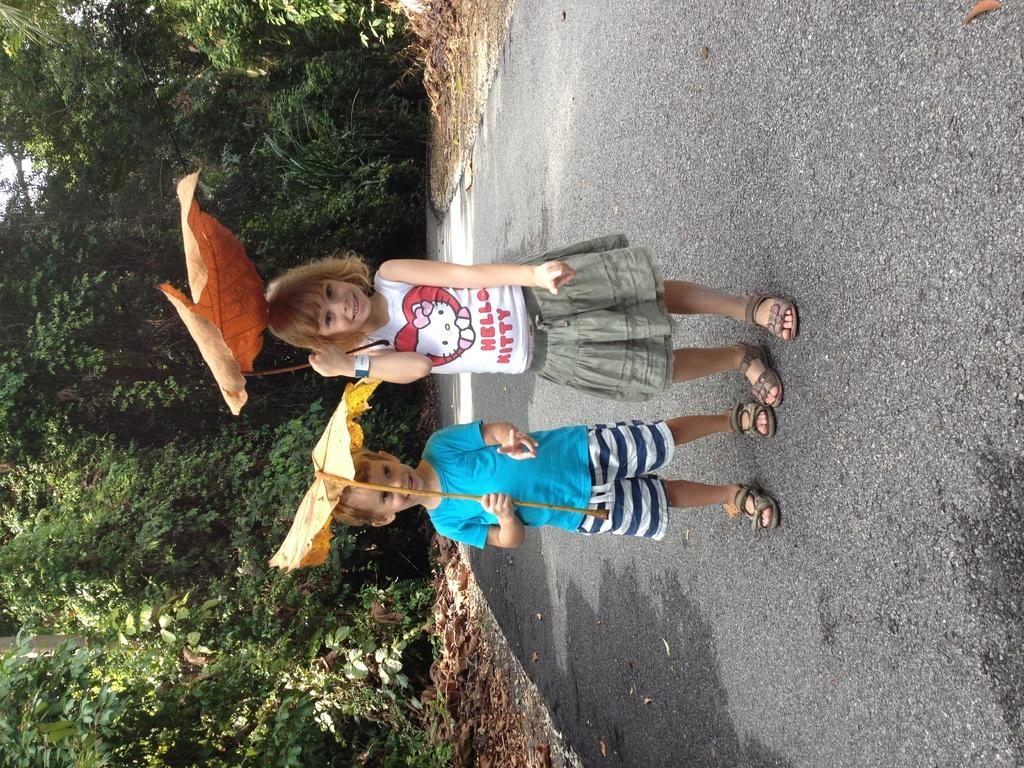<image>
Give a short and clear explanation of the subsequent image. A young girl wears a shirt that that reads HELLO KITTY. 